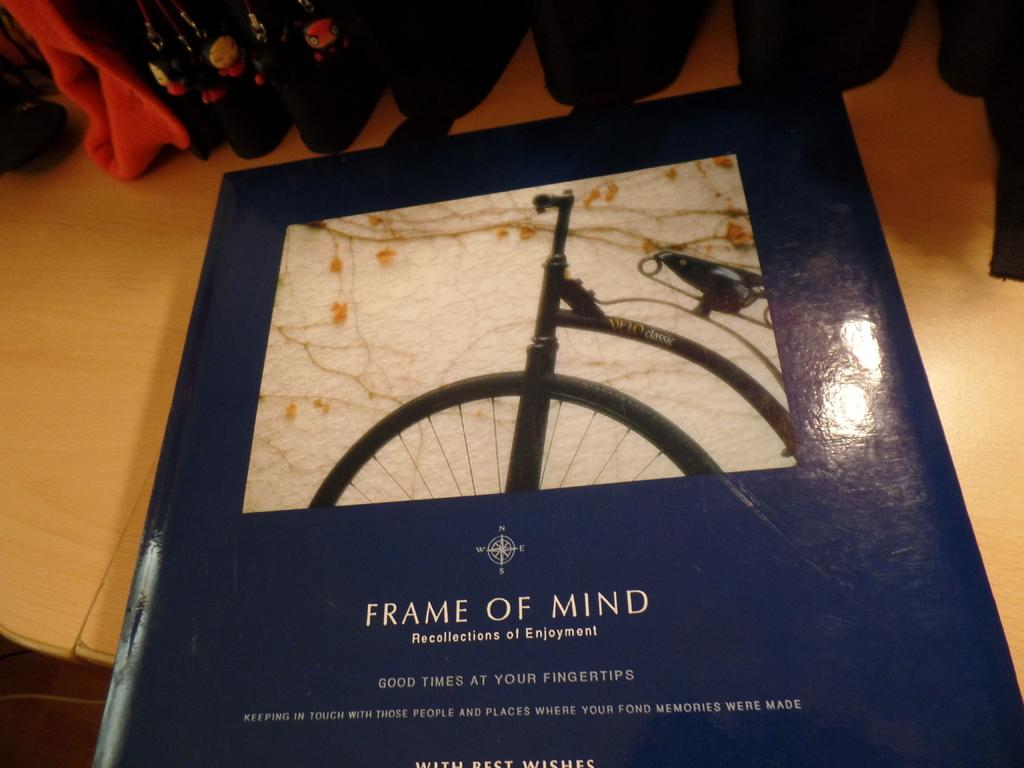What object can be seen in the image related to reading or learning? There is a book in the image. What items are present in the image that might be used for carrying or storing items? There are bags in the image. Can you describe the setting where the image was taken? The image is taken in a room. What type of bait is being used to catch fish in the image? There is no mention of fish or bait in the image; it only features a book and bags in a room. 